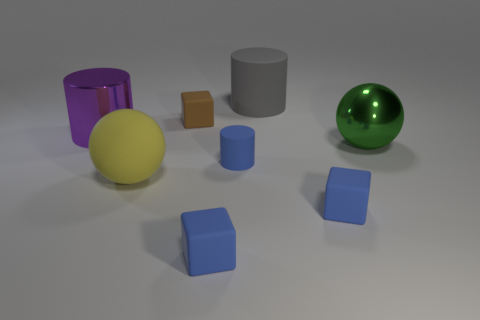How many other things are there of the same color as the small matte cylinder?
Provide a short and direct response. 2. Are there more blue cylinders that are left of the brown cube than big shiny balls left of the large yellow sphere?
Ensure brevity in your answer.  No. Are there any big yellow balls behind the large yellow object?
Your answer should be compact. No. What is the material of the big object that is both in front of the purple metal thing and on the left side of the green sphere?
Ensure brevity in your answer.  Rubber. There is another thing that is the same shape as the green object; what is its color?
Give a very brief answer. Yellow. There is a blue rubber cube on the left side of the big gray rubber cylinder; are there any purple things that are in front of it?
Offer a terse response. No. What size is the brown object?
Provide a succinct answer. Small. What is the shape of the thing that is in front of the green thing and behind the yellow ball?
Ensure brevity in your answer.  Cylinder. How many cyan things are large shiny balls or tiny things?
Keep it short and to the point. 0. There is a ball to the right of the gray cylinder; does it have the same size as the cylinder in front of the green shiny ball?
Provide a short and direct response. No. 